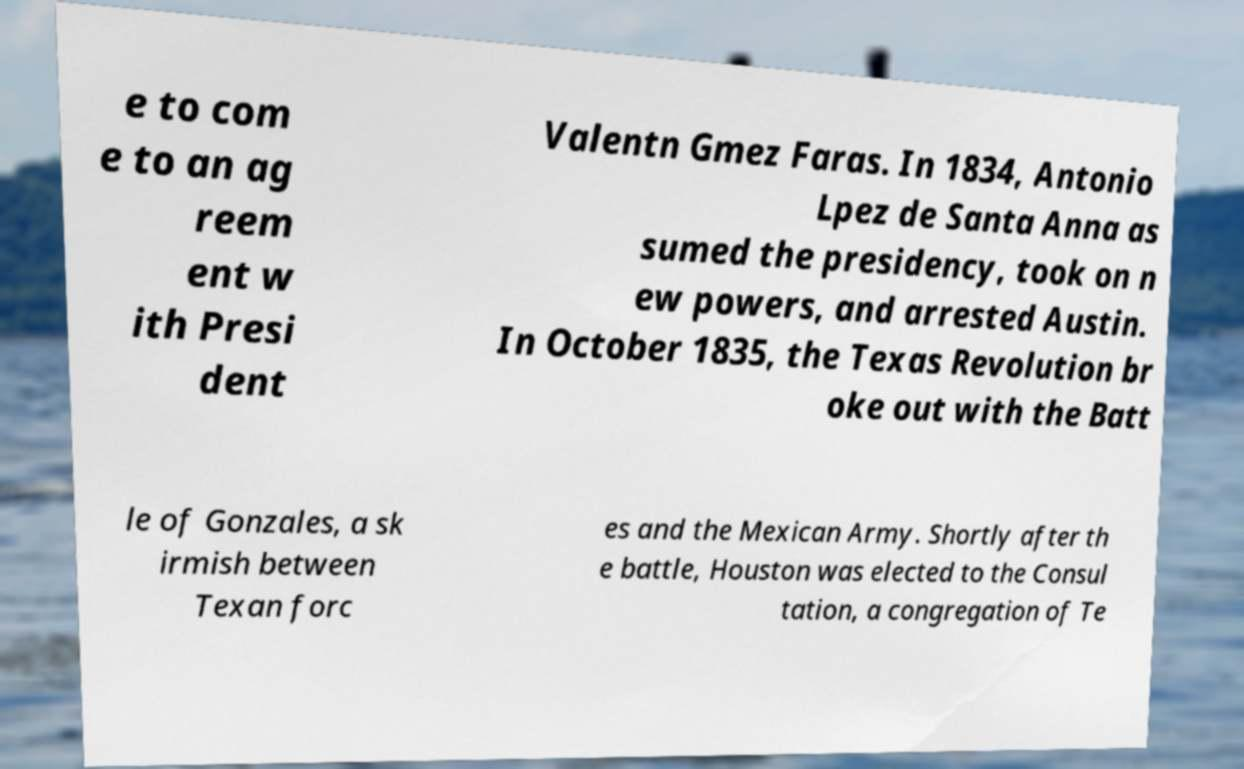For documentation purposes, I need the text within this image transcribed. Could you provide that? e to com e to an ag reem ent w ith Presi dent Valentn Gmez Faras. In 1834, Antonio Lpez de Santa Anna as sumed the presidency, took on n ew powers, and arrested Austin. In October 1835, the Texas Revolution br oke out with the Batt le of Gonzales, a sk irmish between Texan forc es and the Mexican Army. Shortly after th e battle, Houston was elected to the Consul tation, a congregation of Te 